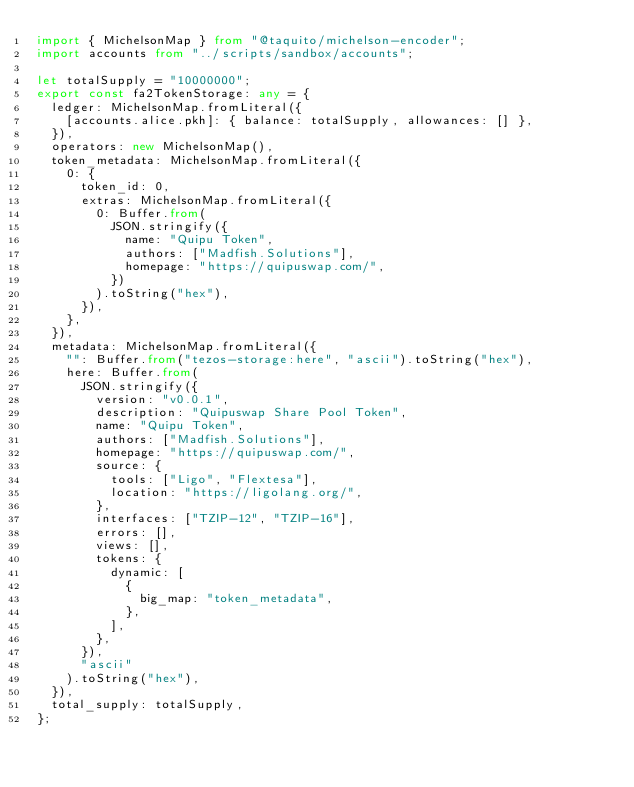<code> <loc_0><loc_0><loc_500><loc_500><_TypeScript_>import { MichelsonMap } from "@taquito/michelson-encoder";
import accounts from "../scripts/sandbox/accounts";

let totalSupply = "10000000";
export const fa2TokenStorage: any = {
  ledger: MichelsonMap.fromLiteral({
    [accounts.alice.pkh]: { balance: totalSupply, allowances: [] },
  }),
  operators: new MichelsonMap(),
  token_metadata: MichelsonMap.fromLiteral({
    0: {
      token_id: 0,
      extras: MichelsonMap.fromLiteral({
        0: Buffer.from(
          JSON.stringify({
            name: "Quipu Token",
            authors: ["Madfish.Solutions"],
            homepage: "https://quipuswap.com/",
          })
        ).toString("hex"),
      }),
    },
  }),
  metadata: MichelsonMap.fromLiteral({
    "": Buffer.from("tezos-storage:here", "ascii").toString("hex"),
    here: Buffer.from(
      JSON.stringify({
        version: "v0.0.1",
        description: "Quipuswap Share Pool Token",
        name: "Quipu Token",
        authors: ["Madfish.Solutions"],
        homepage: "https://quipuswap.com/",
        source: {
          tools: ["Ligo", "Flextesa"],
          location: "https://ligolang.org/",
        },
        interfaces: ["TZIP-12", "TZIP-16"],
        errors: [],
        views: [],
        tokens: {
          dynamic: [
            {
              big_map: "token_metadata",
            },
          ],
        },
      }),
      "ascii"
    ).toString("hex"),
  }),
  total_supply: totalSupply,
};
</code> 